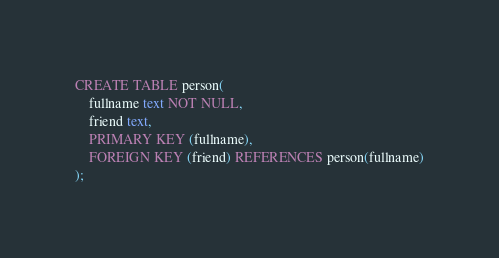<code> <loc_0><loc_0><loc_500><loc_500><_SQL_>CREATE TABLE person(
    fullname text NOT NULL,
    friend text,
    PRIMARY KEY (fullname),
    FOREIGN KEY (friend) REFERENCES person(fullname)
);</code> 